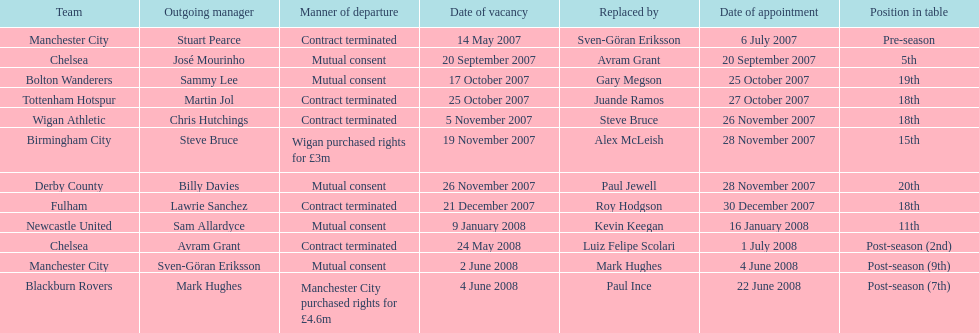In the 2007-08 premier league season, which newly acquired manager had the highest price? Mark Hughes. 